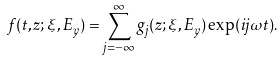Convert formula to latex. <formula><loc_0><loc_0><loc_500><loc_500>f ( t , z ; \xi , E _ { y } ) = \sum _ { j = - \infty } ^ { \infty } g _ { j } ( z ; \xi , E _ { y } ) \exp ( i j \omega t ) .</formula> 